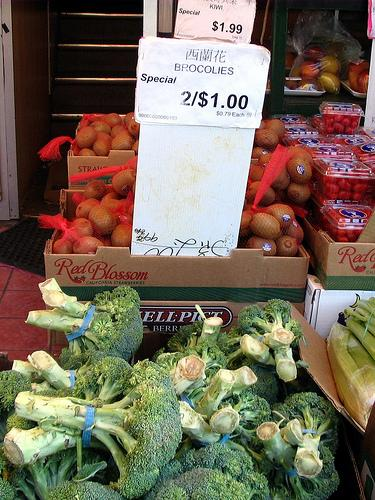Can you determine the pricing and marketing strategy present in the image based on the signages? There are sale signs for kiwi and broccoli, indicating that they might be promoting these items with discounts to attract customers. Identify any additional objects found in the image that might not be directly related to the produce. Some additional objects include red tiled flooring, a black floor mat, and a pricing sign. Explain the image in terms of its visual context and the arrangement of objects in the scene. The image shows a grocery store display with a pile of green broccoli in a box, bags of kiwis, cherry tomatoes in containers, and visible red tiles on the floor. What is the primary object featured in the image, and how would you describe its appearance? The primary object in the image is broccoli, which is green, lush, and presented in various bunches in a box. Identify any anomalies that might look out of the ordinary in this image, if any. There are no significant anomalies in this image; it appears to be a typical produce display in a grocery store. How would you describe the overall sentiment or atmosphere of the image? The image conveys a positive and fresh atmosphere, with a variety of fruits and vegetables available for customers to purchase. Can you identify any fruits and their packaging in the image? Yes, there are kiwis in a bag and a netted bag, and cherry tomatoes in a plastic container and a transparent container. Deduce the primary colors featured in this image based on object descriptions. The primary colors in this image are green (broccoli and celery stalks), red (strawberries, cherry tomatoes, and floor tiles), and orange (bag for kiwis). How are the broccoli heads secured, and what is the color of that securing element? The broccoli heads are secured by blue elastic bands or straps. What materials are used for the different fruits and their packaging in this image? Broccoli is in a cardboard box, kiwis are in a bag and netted bag, and cherry tomatoes are in a plastic and transparent container. 